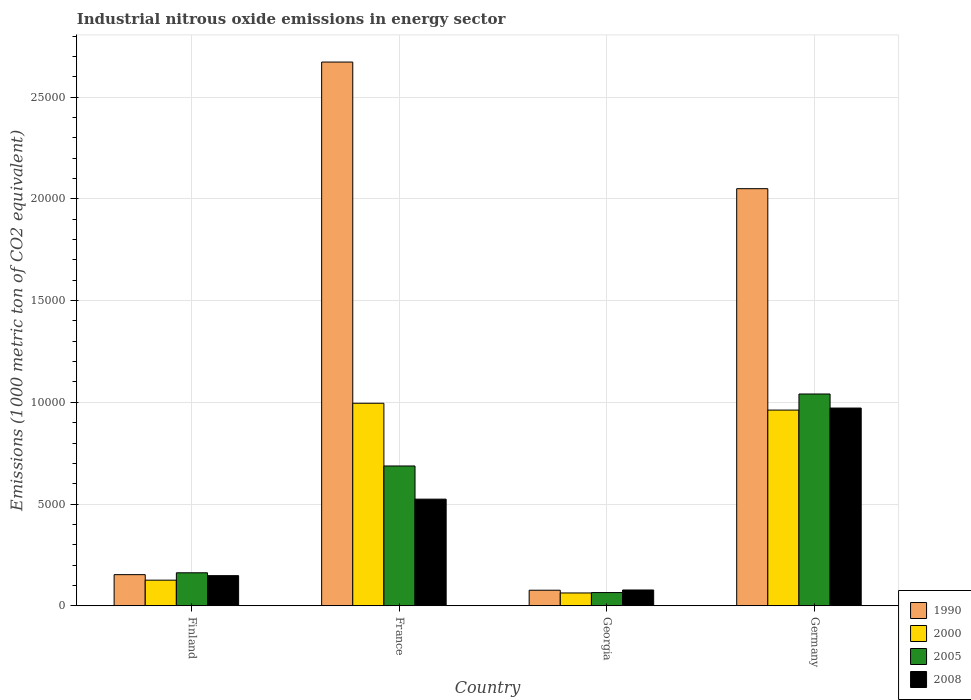How many groups of bars are there?
Make the answer very short. 4. Are the number of bars on each tick of the X-axis equal?
Give a very brief answer. Yes. How many bars are there on the 3rd tick from the right?
Provide a short and direct response. 4. What is the amount of industrial nitrous oxide emitted in 2008 in Germany?
Your response must be concise. 9718.4. Across all countries, what is the maximum amount of industrial nitrous oxide emitted in 1990?
Your response must be concise. 2.67e+04. Across all countries, what is the minimum amount of industrial nitrous oxide emitted in 2008?
Give a very brief answer. 776.5. In which country was the amount of industrial nitrous oxide emitted in 2008 maximum?
Your response must be concise. Germany. In which country was the amount of industrial nitrous oxide emitted in 2008 minimum?
Your answer should be compact. Georgia. What is the total amount of industrial nitrous oxide emitted in 2000 in the graph?
Your answer should be very brief. 2.15e+04. What is the difference between the amount of industrial nitrous oxide emitted in 1990 in Finland and that in Germany?
Provide a succinct answer. -1.90e+04. What is the difference between the amount of industrial nitrous oxide emitted in 1990 in France and the amount of industrial nitrous oxide emitted in 2000 in Germany?
Make the answer very short. 1.71e+04. What is the average amount of industrial nitrous oxide emitted in 2000 per country?
Offer a terse response. 5365.4. What is the difference between the amount of industrial nitrous oxide emitted of/in 2008 and amount of industrial nitrous oxide emitted of/in 2005 in France?
Make the answer very short. -1630.3. What is the ratio of the amount of industrial nitrous oxide emitted in 2008 in Finland to that in France?
Give a very brief answer. 0.28. Is the amount of industrial nitrous oxide emitted in 2000 in France less than that in Georgia?
Give a very brief answer. No. What is the difference between the highest and the second highest amount of industrial nitrous oxide emitted in 2000?
Your response must be concise. 335.9. What is the difference between the highest and the lowest amount of industrial nitrous oxide emitted in 1990?
Ensure brevity in your answer.  2.60e+04. Is the sum of the amount of industrial nitrous oxide emitted in 2000 in Finland and France greater than the maximum amount of industrial nitrous oxide emitted in 1990 across all countries?
Your answer should be compact. No. Is it the case that in every country, the sum of the amount of industrial nitrous oxide emitted in 2005 and amount of industrial nitrous oxide emitted in 1990 is greater than the amount of industrial nitrous oxide emitted in 2008?
Ensure brevity in your answer.  Yes. Are all the bars in the graph horizontal?
Offer a very short reply. No. How many countries are there in the graph?
Offer a terse response. 4. What is the difference between two consecutive major ticks on the Y-axis?
Offer a very short reply. 5000. Are the values on the major ticks of Y-axis written in scientific E-notation?
Offer a very short reply. No. How many legend labels are there?
Provide a succinct answer. 4. What is the title of the graph?
Keep it short and to the point. Industrial nitrous oxide emissions in energy sector. What is the label or title of the Y-axis?
Provide a succinct answer. Emissions (1000 metric ton of CO2 equivalent). What is the Emissions (1000 metric ton of CO2 equivalent) in 1990 in Finland?
Keep it short and to the point. 1530.9. What is the Emissions (1000 metric ton of CO2 equivalent) of 2000 in Finland?
Provide a short and direct response. 1259.4. What is the Emissions (1000 metric ton of CO2 equivalent) of 2005 in Finland?
Give a very brief answer. 1622.4. What is the Emissions (1000 metric ton of CO2 equivalent) in 2008 in Finland?
Your answer should be compact. 1481.5. What is the Emissions (1000 metric ton of CO2 equivalent) in 1990 in France?
Your answer should be compact. 2.67e+04. What is the Emissions (1000 metric ton of CO2 equivalent) of 2000 in France?
Keep it short and to the point. 9953.8. What is the Emissions (1000 metric ton of CO2 equivalent) of 2005 in France?
Keep it short and to the point. 6871.6. What is the Emissions (1000 metric ton of CO2 equivalent) of 2008 in France?
Give a very brief answer. 5241.3. What is the Emissions (1000 metric ton of CO2 equivalent) in 1990 in Georgia?
Your answer should be compact. 765.3. What is the Emissions (1000 metric ton of CO2 equivalent) in 2000 in Georgia?
Provide a succinct answer. 630.5. What is the Emissions (1000 metric ton of CO2 equivalent) in 2005 in Georgia?
Your answer should be very brief. 650.1. What is the Emissions (1000 metric ton of CO2 equivalent) in 2008 in Georgia?
Your response must be concise. 776.5. What is the Emissions (1000 metric ton of CO2 equivalent) of 1990 in Germany?
Make the answer very short. 2.05e+04. What is the Emissions (1000 metric ton of CO2 equivalent) in 2000 in Germany?
Keep it short and to the point. 9617.9. What is the Emissions (1000 metric ton of CO2 equivalent) in 2005 in Germany?
Give a very brief answer. 1.04e+04. What is the Emissions (1000 metric ton of CO2 equivalent) in 2008 in Germany?
Your response must be concise. 9718.4. Across all countries, what is the maximum Emissions (1000 metric ton of CO2 equivalent) of 1990?
Provide a succinct answer. 2.67e+04. Across all countries, what is the maximum Emissions (1000 metric ton of CO2 equivalent) in 2000?
Your response must be concise. 9953.8. Across all countries, what is the maximum Emissions (1000 metric ton of CO2 equivalent) of 2005?
Keep it short and to the point. 1.04e+04. Across all countries, what is the maximum Emissions (1000 metric ton of CO2 equivalent) of 2008?
Provide a short and direct response. 9718.4. Across all countries, what is the minimum Emissions (1000 metric ton of CO2 equivalent) in 1990?
Your response must be concise. 765.3. Across all countries, what is the minimum Emissions (1000 metric ton of CO2 equivalent) of 2000?
Your answer should be very brief. 630.5. Across all countries, what is the minimum Emissions (1000 metric ton of CO2 equivalent) of 2005?
Make the answer very short. 650.1. Across all countries, what is the minimum Emissions (1000 metric ton of CO2 equivalent) of 2008?
Keep it short and to the point. 776.5. What is the total Emissions (1000 metric ton of CO2 equivalent) in 1990 in the graph?
Make the answer very short. 4.95e+04. What is the total Emissions (1000 metric ton of CO2 equivalent) in 2000 in the graph?
Provide a short and direct response. 2.15e+04. What is the total Emissions (1000 metric ton of CO2 equivalent) in 2005 in the graph?
Provide a short and direct response. 1.96e+04. What is the total Emissions (1000 metric ton of CO2 equivalent) of 2008 in the graph?
Provide a short and direct response. 1.72e+04. What is the difference between the Emissions (1000 metric ton of CO2 equivalent) of 1990 in Finland and that in France?
Offer a terse response. -2.52e+04. What is the difference between the Emissions (1000 metric ton of CO2 equivalent) of 2000 in Finland and that in France?
Keep it short and to the point. -8694.4. What is the difference between the Emissions (1000 metric ton of CO2 equivalent) of 2005 in Finland and that in France?
Your response must be concise. -5249.2. What is the difference between the Emissions (1000 metric ton of CO2 equivalent) in 2008 in Finland and that in France?
Offer a very short reply. -3759.8. What is the difference between the Emissions (1000 metric ton of CO2 equivalent) of 1990 in Finland and that in Georgia?
Make the answer very short. 765.6. What is the difference between the Emissions (1000 metric ton of CO2 equivalent) in 2000 in Finland and that in Georgia?
Offer a very short reply. 628.9. What is the difference between the Emissions (1000 metric ton of CO2 equivalent) in 2005 in Finland and that in Georgia?
Offer a terse response. 972.3. What is the difference between the Emissions (1000 metric ton of CO2 equivalent) in 2008 in Finland and that in Georgia?
Offer a very short reply. 705. What is the difference between the Emissions (1000 metric ton of CO2 equivalent) in 1990 in Finland and that in Germany?
Ensure brevity in your answer.  -1.90e+04. What is the difference between the Emissions (1000 metric ton of CO2 equivalent) in 2000 in Finland and that in Germany?
Your response must be concise. -8358.5. What is the difference between the Emissions (1000 metric ton of CO2 equivalent) in 2005 in Finland and that in Germany?
Your response must be concise. -8786.5. What is the difference between the Emissions (1000 metric ton of CO2 equivalent) of 2008 in Finland and that in Germany?
Keep it short and to the point. -8236.9. What is the difference between the Emissions (1000 metric ton of CO2 equivalent) in 1990 in France and that in Georgia?
Offer a terse response. 2.60e+04. What is the difference between the Emissions (1000 metric ton of CO2 equivalent) of 2000 in France and that in Georgia?
Make the answer very short. 9323.3. What is the difference between the Emissions (1000 metric ton of CO2 equivalent) in 2005 in France and that in Georgia?
Make the answer very short. 6221.5. What is the difference between the Emissions (1000 metric ton of CO2 equivalent) of 2008 in France and that in Georgia?
Keep it short and to the point. 4464.8. What is the difference between the Emissions (1000 metric ton of CO2 equivalent) of 1990 in France and that in Germany?
Offer a very short reply. 6222.7. What is the difference between the Emissions (1000 metric ton of CO2 equivalent) in 2000 in France and that in Germany?
Ensure brevity in your answer.  335.9. What is the difference between the Emissions (1000 metric ton of CO2 equivalent) in 2005 in France and that in Germany?
Keep it short and to the point. -3537.3. What is the difference between the Emissions (1000 metric ton of CO2 equivalent) in 2008 in France and that in Germany?
Ensure brevity in your answer.  -4477.1. What is the difference between the Emissions (1000 metric ton of CO2 equivalent) of 1990 in Georgia and that in Germany?
Your answer should be compact. -1.97e+04. What is the difference between the Emissions (1000 metric ton of CO2 equivalent) of 2000 in Georgia and that in Germany?
Make the answer very short. -8987.4. What is the difference between the Emissions (1000 metric ton of CO2 equivalent) in 2005 in Georgia and that in Germany?
Give a very brief answer. -9758.8. What is the difference between the Emissions (1000 metric ton of CO2 equivalent) in 2008 in Georgia and that in Germany?
Give a very brief answer. -8941.9. What is the difference between the Emissions (1000 metric ton of CO2 equivalent) in 1990 in Finland and the Emissions (1000 metric ton of CO2 equivalent) in 2000 in France?
Make the answer very short. -8422.9. What is the difference between the Emissions (1000 metric ton of CO2 equivalent) in 1990 in Finland and the Emissions (1000 metric ton of CO2 equivalent) in 2005 in France?
Provide a short and direct response. -5340.7. What is the difference between the Emissions (1000 metric ton of CO2 equivalent) in 1990 in Finland and the Emissions (1000 metric ton of CO2 equivalent) in 2008 in France?
Provide a succinct answer. -3710.4. What is the difference between the Emissions (1000 metric ton of CO2 equivalent) of 2000 in Finland and the Emissions (1000 metric ton of CO2 equivalent) of 2005 in France?
Your answer should be very brief. -5612.2. What is the difference between the Emissions (1000 metric ton of CO2 equivalent) of 2000 in Finland and the Emissions (1000 metric ton of CO2 equivalent) of 2008 in France?
Provide a succinct answer. -3981.9. What is the difference between the Emissions (1000 metric ton of CO2 equivalent) of 2005 in Finland and the Emissions (1000 metric ton of CO2 equivalent) of 2008 in France?
Provide a succinct answer. -3618.9. What is the difference between the Emissions (1000 metric ton of CO2 equivalent) in 1990 in Finland and the Emissions (1000 metric ton of CO2 equivalent) in 2000 in Georgia?
Provide a succinct answer. 900.4. What is the difference between the Emissions (1000 metric ton of CO2 equivalent) in 1990 in Finland and the Emissions (1000 metric ton of CO2 equivalent) in 2005 in Georgia?
Your answer should be compact. 880.8. What is the difference between the Emissions (1000 metric ton of CO2 equivalent) of 1990 in Finland and the Emissions (1000 metric ton of CO2 equivalent) of 2008 in Georgia?
Your answer should be very brief. 754.4. What is the difference between the Emissions (1000 metric ton of CO2 equivalent) of 2000 in Finland and the Emissions (1000 metric ton of CO2 equivalent) of 2005 in Georgia?
Keep it short and to the point. 609.3. What is the difference between the Emissions (1000 metric ton of CO2 equivalent) of 2000 in Finland and the Emissions (1000 metric ton of CO2 equivalent) of 2008 in Georgia?
Provide a short and direct response. 482.9. What is the difference between the Emissions (1000 metric ton of CO2 equivalent) in 2005 in Finland and the Emissions (1000 metric ton of CO2 equivalent) in 2008 in Georgia?
Keep it short and to the point. 845.9. What is the difference between the Emissions (1000 metric ton of CO2 equivalent) in 1990 in Finland and the Emissions (1000 metric ton of CO2 equivalent) in 2000 in Germany?
Make the answer very short. -8087. What is the difference between the Emissions (1000 metric ton of CO2 equivalent) of 1990 in Finland and the Emissions (1000 metric ton of CO2 equivalent) of 2005 in Germany?
Provide a succinct answer. -8878. What is the difference between the Emissions (1000 metric ton of CO2 equivalent) in 1990 in Finland and the Emissions (1000 metric ton of CO2 equivalent) in 2008 in Germany?
Make the answer very short. -8187.5. What is the difference between the Emissions (1000 metric ton of CO2 equivalent) in 2000 in Finland and the Emissions (1000 metric ton of CO2 equivalent) in 2005 in Germany?
Provide a short and direct response. -9149.5. What is the difference between the Emissions (1000 metric ton of CO2 equivalent) of 2000 in Finland and the Emissions (1000 metric ton of CO2 equivalent) of 2008 in Germany?
Provide a short and direct response. -8459. What is the difference between the Emissions (1000 metric ton of CO2 equivalent) in 2005 in Finland and the Emissions (1000 metric ton of CO2 equivalent) in 2008 in Germany?
Your response must be concise. -8096. What is the difference between the Emissions (1000 metric ton of CO2 equivalent) in 1990 in France and the Emissions (1000 metric ton of CO2 equivalent) in 2000 in Georgia?
Make the answer very short. 2.61e+04. What is the difference between the Emissions (1000 metric ton of CO2 equivalent) in 1990 in France and the Emissions (1000 metric ton of CO2 equivalent) in 2005 in Georgia?
Your answer should be very brief. 2.61e+04. What is the difference between the Emissions (1000 metric ton of CO2 equivalent) in 1990 in France and the Emissions (1000 metric ton of CO2 equivalent) in 2008 in Georgia?
Keep it short and to the point. 2.59e+04. What is the difference between the Emissions (1000 metric ton of CO2 equivalent) of 2000 in France and the Emissions (1000 metric ton of CO2 equivalent) of 2005 in Georgia?
Provide a succinct answer. 9303.7. What is the difference between the Emissions (1000 metric ton of CO2 equivalent) of 2000 in France and the Emissions (1000 metric ton of CO2 equivalent) of 2008 in Georgia?
Your response must be concise. 9177.3. What is the difference between the Emissions (1000 metric ton of CO2 equivalent) in 2005 in France and the Emissions (1000 metric ton of CO2 equivalent) in 2008 in Georgia?
Ensure brevity in your answer.  6095.1. What is the difference between the Emissions (1000 metric ton of CO2 equivalent) of 1990 in France and the Emissions (1000 metric ton of CO2 equivalent) of 2000 in Germany?
Provide a succinct answer. 1.71e+04. What is the difference between the Emissions (1000 metric ton of CO2 equivalent) of 1990 in France and the Emissions (1000 metric ton of CO2 equivalent) of 2005 in Germany?
Provide a short and direct response. 1.63e+04. What is the difference between the Emissions (1000 metric ton of CO2 equivalent) of 1990 in France and the Emissions (1000 metric ton of CO2 equivalent) of 2008 in Germany?
Provide a short and direct response. 1.70e+04. What is the difference between the Emissions (1000 metric ton of CO2 equivalent) of 2000 in France and the Emissions (1000 metric ton of CO2 equivalent) of 2005 in Germany?
Your answer should be compact. -455.1. What is the difference between the Emissions (1000 metric ton of CO2 equivalent) of 2000 in France and the Emissions (1000 metric ton of CO2 equivalent) of 2008 in Germany?
Offer a terse response. 235.4. What is the difference between the Emissions (1000 metric ton of CO2 equivalent) in 2005 in France and the Emissions (1000 metric ton of CO2 equivalent) in 2008 in Germany?
Your response must be concise. -2846.8. What is the difference between the Emissions (1000 metric ton of CO2 equivalent) in 1990 in Georgia and the Emissions (1000 metric ton of CO2 equivalent) in 2000 in Germany?
Offer a terse response. -8852.6. What is the difference between the Emissions (1000 metric ton of CO2 equivalent) of 1990 in Georgia and the Emissions (1000 metric ton of CO2 equivalent) of 2005 in Germany?
Give a very brief answer. -9643.6. What is the difference between the Emissions (1000 metric ton of CO2 equivalent) of 1990 in Georgia and the Emissions (1000 metric ton of CO2 equivalent) of 2008 in Germany?
Give a very brief answer. -8953.1. What is the difference between the Emissions (1000 metric ton of CO2 equivalent) of 2000 in Georgia and the Emissions (1000 metric ton of CO2 equivalent) of 2005 in Germany?
Your answer should be compact. -9778.4. What is the difference between the Emissions (1000 metric ton of CO2 equivalent) of 2000 in Georgia and the Emissions (1000 metric ton of CO2 equivalent) of 2008 in Germany?
Your response must be concise. -9087.9. What is the difference between the Emissions (1000 metric ton of CO2 equivalent) in 2005 in Georgia and the Emissions (1000 metric ton of CO2 equivalent) in 2008 in Germany?
Provide a succinct answer. -9068.3. What is the average Emissions (1000 metric ton of CO2 equivalent) in 1990 per country?
Offer a terse response. 1.24e+04. What is the average Emissions (1000 metric ton of CO2 equivalent) of 2000 per country?
Offer a very short reply. 5365.4. What is the average Emissions (1000 metric ton of CO2 equivalent) in 2005 per country?
Your response must be concise. 4888.25. What is the average Emissions (1000 metric ton of CO2 equivalent) of 2008 per country?
Provide a short and direct response. 4304.43. What is the difference between the Emissions (1000 metric ton of CO2 equivalent) of 1990 and Emissions (1000 metric ton of CO2 equivalent) of 2000 in Finland?
Your answer should be very brief. 271.5. What is the difference between the Emissions (1000 metric ton of CO2 equivalent) in 1990 and Emissions (1000 metric ton of CO2 equivalent) in 2005 in Finland?
Ensure brevity in your answer.  -91.5. What is the difference between the Emissions (1000 metric ton of CO2 equivalent) in 1990 and Emissions (1000 metric ton of CO2 equivalent) in 2008 in Finland?
Make the answer very short. 49.4. What is the difference between the Emissions (1000 metric ton of CO2 equivalent) in 2000 and Emissions (1000 metric ton of CO2 equivalent) in 2005 in Finland?
Ensure brevity in your answer.  -363. What is the difference between the Emissions (1000 metric ton of CO2 equivalent) of 2000 and Emissions (1000 metric ton of CO2 equivalent) of 2008 in Finland?
Your answer should be compact. -222.1. What is the difference between the Emissions (1000 metric ton of CO2 equivalent) of 2005 and Emissions (1000 metric ton of CO2 equivalent) of 2008 in Finland?
Give a very brief answer. 140.9. What is the difference between the Emissions (1000 metric ton of CO2 equivalent) of 1990 and Emissions (1000 metric ton of CO2 equivalent) of 2000 in France?
Your answer should be very brief. 1.68e+04. What is the difference between the Emissions (1000 metric ton of CO2 equivalent) of 1990 and Emissions (1000 metric ton of CO2 equivalent) of 2005 in France?
Ensure brevity in your answer.  1.99e+04. What is the difference between the Emissions (1000 metric ton of CO2 equivalent) in 1990 and Emissions (1000 metric ton of CO2 equivalent) in 2008 in France?
Your answer should be compact. 2.15e+04. What is the difference between the Emissions (1000 metric ton of CO2 equivalent) of 2000 and Emissions (1000 metric ton of CO2 equivalent) of 2005 in France?
Your response must be concise. 3082.2. What is the difference between the Emissions (1000 metric ton of CO2 equivalent) of 2000 and Emissions (1000 metric ton of CO2 equivalent) of 2008 in France?
Ensure brevity in your answer.  4712.5. What is the difference between the Emissions (1000 metric ton of CO2 equivalent) of 2005 and Emissions (1000 metric ton of CO2 equivalent) of 2008 in France?
Provide a succinct answer. 1630.3. What is the difference between the Emissions (1000 metric ton of CO2 equivalent) in 1990 and Emissions (1000 metric ton of CO2 equivalent) in 2000 in Georgia?
Make the answer very short. 134.8. What is the difference between the Emissions (1000 metric ton of CO2 equivalent) in 1990 and Emissions (1000 metric ton of CO2 equivalent) in 2005 in Georgia?
Give a very brief answer. 115.2. What is the difference between the Emissions (1000 metric ton of CO2 equivalent) of 1990 and Emissions (1000 metric ton of CO2 equivalent) of 2008 in Georgia?
Your response must be concise. -11.2. What is the difference between the Emissions (1000 metric ton of CO2 equivalent) of 2000 and Emissions (1000 metric ton of CO2 equivalent) of 2005 in Georgia?
Make the answer very short. -19.6. What is the difference between the Emissions (1000 metric ton of CO2 equivalent) in 2000 and Emissions (1000 metric ton of CO2 equivalent) in 2008 in Georgia?
Make the answer very short. -146. What is the difference between the Emissions (1000 metric ton of CO2 equivalent) of 2005 and Emissions (1000 metric ton of CO2 equivalent) of 2008 in Georgia?
Your answer should be very brief. -126.4. What is the difference between the Emissions (1000 metric ton of CO2 equivalent) of 1990 and Emissions (1000 metric ton of CO2 equivalent) of 2000 in Germany?
Provide a succinct answer. 1.09e+04. What is the difference between the Emissions (1000 metric ton of CO2 equivalent) in 1990 and Emissions (1000 metric ton of CO2 equivalent) in 2005 in Germany?
Your answer should be compact. 1.01e+04. What is the difference between the Emissions (1000 metric ton of CO2 equivalent) in 1990 and Emissions (1000 metric ton of CO2 equivalent) in 2008 in Germany?
Provide a succinct answer. 1.08e+04. What is the difference between the Emissions (1000 metric ton of CO2 equivalent) of 2000 and Emissions (1000 metric ton of CO2 equivalent) of 2005 in Germany?
Offer a very short reply. -791. What is the difference between the Emissions (1000 metric ton of CO2 equivalent) of 2000 and Emissions (1000 metric ton of CO2 equivalent) of 2008 in Germany?
Give a very brief answer. -100.5. What is the difference between the Emissions (1000 metric ton of CO2 equivalent) of 2005 and Emissions (1000 metric ton of CO2 equivalent) of 2008 in Germany?
Provide a short and direct response. 690.5. What is the ratio of the Emissions (1000 metric ton of CO2 equivalent) of 1990 in Finland to that in France?
Your answer should be compact. 0.06. What is the ratio of the Emissions (1000 metric ton of CO2 equivalent) in 2000 in Finland to that in France?
Ensure brevity in your answer.  0.13. What is the ratio of the Emissions (1000 metric ton of CO2 equivalent) of 2005 in Finland to that in France?
Your response must be concise. 0.24. What is the ratio of the Emissions (1000 metric ton of CO2 equivalent) in 2008 in Finland to that in France?
Provide a short and direct response. 0.28. What is the ratio of the Emissions (1000 metric ton of CO2 equivalent) of 1990 in Finland to that in Georgia?
Your response must be concise. 2. What is the ratio of the Emissions (1000 metric ton of CO2 equivalent) of 2000 in Finland to that in Georgia?
Make the answer very short. 2. What is the ratio of the Emissions (1000 metric ton of CO2 equivalent) of 2005 in Finland to that in Georgia?
Offer a terse response. 2.5. What is the ratio of the Emissions (1000 metric ton of CO2 equivalent) of 2008 in Finland to that in Georgia?
Your answer should be compact. 1.91. What is the ratio of the Emissions (1000 metric ton of CO2 equivalent) in 1990 in Finland to that in Germany?
Offer a very short reply. 0.07. What is the ratio of the Emissions (1000 metric ton of CO2 equivalent) in 2000 in Finland to that in Germany?
Ensure brevity in your answer.  0.13. What is the ratio of the Emissions (1000 metric ton of CO2 equivalent) in 2005 in Finland to that in Germany?
Your response must be concise. 0.16. What is the ratio of the Emissions (1000 metric ton of CO2 equivalent) of 2008 in Finland to that in Germany?
Keep it short and to the point. 0.15. What is the ratio of the Emissions (1000 metric ton of CO2 equivalent) of 1990 in France to that in Georgia?
Provide a short and direct response. 34.92. What is the ratio of the Emissions (1000 metric ton of CO2 equivalent) in 2000 in France to that in Georgia?
Give a very brief answer. 15.79. What is the ratio of the Emissions (1000 metric ton of CO2 equivalent) of 2005 in France to that in Georgia?
Your answer should be compact. 10.57. What is the ratio of the Emissions (1000 metric ton of CO2 equivalent) in 2008 in France to that in Georgia?
Provide a short and direct response. 6.75. What is the ratio of the Emissions (1000 metric ton of CO2 equivalent) of 1990 in France to that in Germany?
Keep it short and to the point. 1.3. What is the ratio of the Emissions (1000 metric ton of CO2 equivalent) of 2000 in France to that in Germany?
Offer a very short reply. 1.03. What is the ratio of the Emissions (1000 metric ton of CO2 equivalent) of 2005 in France to that in Germany?
Give a very brief answer. 0.66. What is the ratio of the Emissions (1000 metric ton of CO2 equivalent) of 2008 in France to that in Germany?
Keep it short and to the point. 0.54. What is the ratio of the Emissions (1000 metric ton of CO2 equivalent) of 1990 in Georgia to that in Germany?
Offer a very short reply. 0.04. What is the ratio of the Emissions (1000 metric ton of CO2 equivalent) in 2000 in Georgia to that in Germany?
Make the answer very short. 0.07. What is the ratio of the Emissions (1000 metric ton of CO2 equivalent) of 2005 in Georgia to that in Germany?
Your answer should be very brief. 0.06. What is the ratio of the Emissions (1000 metric ton of CO2 equivalent) of 2008 in Georgia to that in Germany?
Offer a very short reply. 0.08. What is the difference between the highest and the second highest Emissions (1000 metric ton of CO2 equivalent) in 1990?
Your response must be concise. 6222.7. What is the difference between the highest and the second highest Emissions (1000 metric ton of CO2 equivalent) of 2000?
Offer a very short reply. 335.9. What is the difference between the highest and the second highest Emissions (1000 metric ton of CO2 equivalent) in 2005?
Keep it short and to the point. 3537.3. What is the difference between the highest and the second highest Emissions (1000 metric ton of CO2 equivalent) in 2008?
Keep it short and to the point. 4477.1. What is the difference between the highest and the lowest Emissions (1000 metric ton of CO2 equivalent) in 1990?
Offer a very short reply. 2.60e+04. What is the difference between the highest and the lowest Emissions (1000 metric ton of CO2 equivalent) in 2000?
Keep it short and to the point. 9323.3. What is the difference between the highest and the lowest Emissions (1000 metric ton of CO2 equivalent) in 2005?
Provide a short and direct response. 9758.8. What is the difference between the highest and the lowest Emissions (1000 metric ton of CO2 equivalent) in 2008?
Your answer should be compact. 8941.9. 